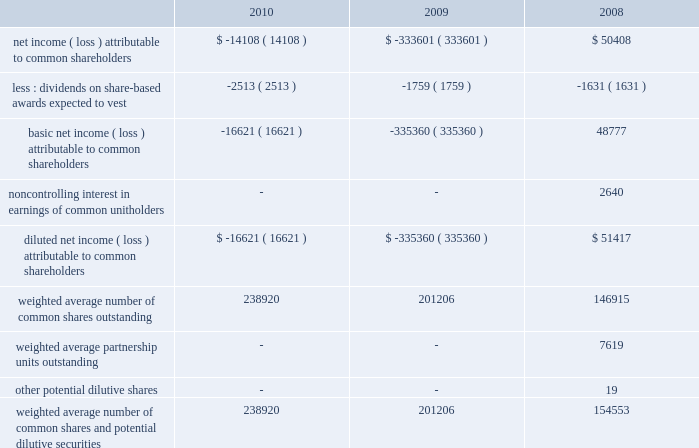54| | duke realty corporation annual report 2010 .
Weighted average number of common shares and potential diluted securities 238920 201206 154553 criteria in fasb asc 360-20 related to the terms of the transactions and any continuing involvement in the form of management or financial assistance from the seller associated with the properties .
We make judgments based on the specific terms of each transaction as to the amount of the total profit from the transaction that we recognize considering factors such as continuing ownership interest we may have with the buyer ( 201cpartial sales 201d ) and our level of future involvement with the property or the buyer that acquires the assets .
If the full accrual sales criteria are not met , we defer gain recognition and account for the continued operations of the property by applying the finance , installment or cost recovery methods , as appropriate , until the full accrual sales criteria are met .
Estimated future costs to be incurred after completion of each sale are included in the determination of the gain on sales .
To the extent that a property has had operations prior to sale , and that we do not have continuing involvement with the property , gains from sales of depreciated property are included in discontinued operations and the proceeds from the sale of these held-for-rental properties are classified in the investing activities section of the consolidated statements of cash flows .
Gains or losses from our sale of properties that were developed or repositioned with the intent to sell and not for long-term rental ( 201cbuild-for-sale 201d properties ) are classified as gain on sale of properties in the consolidated statements of operations .
Other rental properties that do not meet the criteria for presentation as discontinued operations are also classified as gain on sale of properties in the consolidated statements of operations .
Net income ( loss ) per common share basic net income ( loss ) per common share is computed by dividing net income ( loss ) attributable to common shareholders , less dividends on share- based awards expected to vest , by the weighted average number of common shares outstanding for the period .
Diluted net income ( loss ) per common share is computed by dividing the sum of basic net income ( loss ) attributable to common shareholders and the noncontrolling interest in earnings allocable to units not owned by us ( to the extent the units are dilutive ) , by the sum of the weighted average number of common shares outstanding and , to the extent they are dilutive , partnership units outstanding , as well as any potential dilutive securities for the period .
During the first quarter of 2009 , we adopted a new accounting standard ( fasb asc 260-10 ) on participating securities , which we have applied retrospectively to prior period calculations of basic and diluted earnings per common share .
Pursuant to this new standard , certain of our share-based awards are considered participating securities because they earn dividend equivalents that are not forfeited even if the underlying award does not vest .
The following table reconciles the components of basic and diluted net income ( loss ) per common share ( in thousands ) : .
What is the basic net income ( loss ) attributable to common shareholders as a percentage of diluted net income ( loss ) attributable to common shareholders in 2008? 
Computations: ((48777 / 51417) * 100)
Answer: 94.86551. 